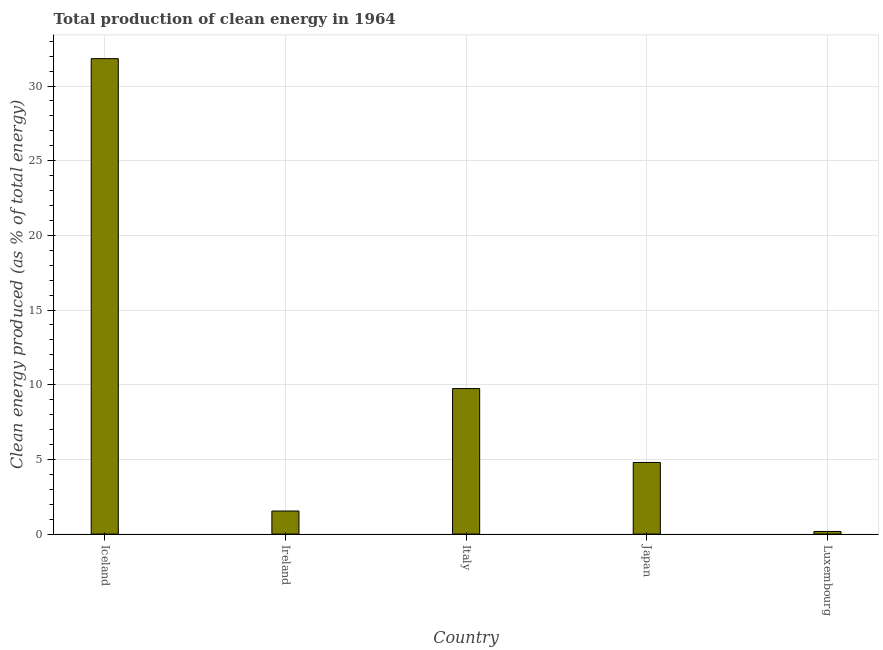Does the graph contain any zero values?
Offer a terse response. No. Does the graph contain grids?
Make the answer very short. Yes. What is the title of the graph?
Provide a succinct answer. Total production of clean energy in 1964. What is the label or title of the X-axis?
Provide a succinct answer. Country. What is the label or title of the Y-axis?
Make the answer very short. Clean energy produced (as % of total energy). What is the production of clean energy in Luxembourg?
Ensure brevity in your answer.  0.18. Across all countries, what is the maximum production of clean energy?
Your answer should be very brief. 31.83. Across all countries, what is the minimum production of clean energy?
Your response must be concise. 0.18. In which country was the production of clean energy maximum?
Offer a terse response. Iceland. In which country was the production of clean energy minimum?
Your answer should be very brief. Luxembourg. What is the sum of the production of clean energy?
Keep it short and to the point. 48.09. What is the difference between the production of clean energy in Iceland and Luxembourg?
Make the answer very short. 31.66. What is the average production of clean energy per country?
Provide a short and direct response. 9.62. What is the median production of clean energy?
Your response must be concise. 4.8. What is the ratio of the production of clean energy in Iceland to that in Ireland?
Your response must be concise. 20.6. Is the difference between the production of clean energy in Japan and Luxembourg greater than the difference between any two countries?
Make the answer very short. No. What is the difference between the highest and the second highest production of clean energy?
Your answer should be compact. 22.09. Is the sum of the production of clean energy in Italy and Luxembourg greater than the maximum production of clean energy across all countries?
Provide a succinct answer. No. What is the difference between the highest and the lowest production of clean energy?
Your answer should be very brief. 31.66. Are all the bars in the graph horizontal?
Offer a very short reply. No. Are the values on the major ticks of Y-axis written in scientific E-notation?
Provide a short and direct response. No. What is the Clean energy produced (as % of total energy) in Iceland?
Offer a terse response. 31.83. What is the Clean energy produced (as % of total energy) in Ireland?
Make the answer very short. 1.55. What is the Clean energy produced (as % of total energy) of Italy?
Keep it short and to the point. 9.74. What is the Clean energy produced (as % of total energy) in Japan?
Keep it short and to the point. 4.8. What is the Clean energy produced (as % of total energy) of Luxembourg?
Provide a short and direct response. 0.18. What is the difference between the Clean energy produced (as % of total energy) in Iceland and Ireland?
Your answer should be compact. 30.29. What is the difference between the Clean energy produced (as % of total energy) in Iceland and Italy?
Give a very brief answer. 22.09. What is the difference between the Clean energy produced (as % of total energy) in Iceland and Japan?
Your answer should be very brief. 27.04. What is the difference between the Clean energy produced (as % of total energy) in Iceland and Luxembourg?
Your answer should be compact. 31.66. What is the difference between the Clean energy produced (as % of total energy) in Ireland and Italy?
Your answer should be very brief. -8.2. What is the difference between the Clean energy produced (as % of total energy) in Ireland and Japan?
Your answer should be compact. -3.25. What is the difference between the Clean energy produced (as % of total energy) in Ireland and Luxembourg?
Your answer should be compact. 1.37. What is the difference between the Clean energy produced (as % of total energy) in Italy and Japan?
Offer a very short reply. 4.95. What is the difference between the Clean energy produced (as % of total energy) in Italy and Luxembourg?
Give a very brief answer. 9.57. What is the difference between the Clean energy produced (as % of total energy) in Japan and Luxembourg?
Your response must be concise. 4.62. What is the ratio of the Clean energy produced (as % of total energy) in Iceland to that in Ireland?
Your response must be concise. 20.6. What is the ratio of the Clean energy produced (as % of total energy) in Iceland to that in Italy?
Your answer should be compact. 3.27. What is the ratio of the Clean energy produced (as % of total energy) in Iceland to that in Japan?
Ensure brevity in your answer.  6.64. What is the ratio of the Clean energy produced (as % of total energy) in Iceland to that in Luxembourg?
Provide a succinct answer. 180.36. What is the ratio of the Clean energy produced (as % of total energy) in Ireland to that in Italy?
Ensure brevity in your answer.  0.16. What is the ratio of the Clean energy produced (as % of total energy) in Ireland to that in Japan?
Keep it short and to the point. 0.32. What is the ratio of the Clean energy produced (as % of total energy) in Ireland to that in Luxembourg?
Offer a terse response. 8.76. What is the ratio of the Clean energy produced (as % of total energy) in Italy to that in Japan?
Your answer should be compact. 2.03. What is the ratio of the Clean energy produced (as % of total energy) in Italy to that in Luxembourg?
Your answer should be compact. 55.21. What is the ratio of the Clean energy produced (as % of total energy) in Japan to that in Luxembourg?
Offer a very short reply. 27.18. 